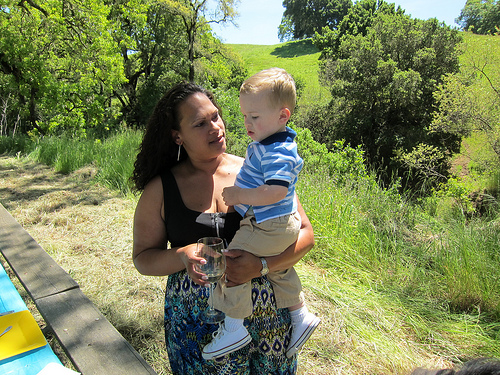<image>
Is the baby on the woman? Yes. Looking at the image, I can see the baby is positioned on top of the woman, with the woman providing support. Where is the mom in relation to the baby? Is it in front of the baby? Yes. The mom is positioned in front of the baby, appearing closer to the camera viewpoint. 